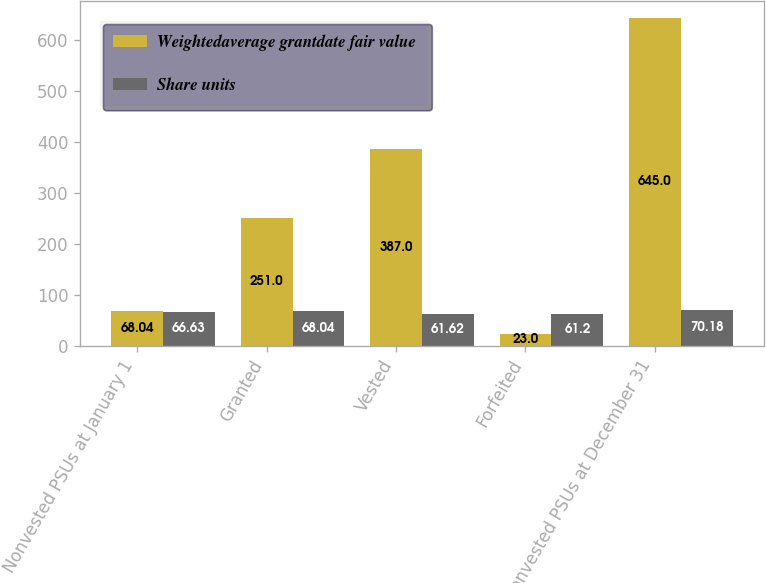Convert chart to OTSL. <chart><loc_0><loc_0><loc_500><loc_500><stacked_bar_chart><ecel><fcel>Nonvested PSUs at January 1<fcel>Granted<fcel>Vested<fcel>Forfeited<fcel>Nonvested PSUs at December 31<nl><fcel>Weightedaverage grantdate fair value<fcel>68.04<fcel>251<fcel>387<fcel>23<fcel>645<nl><fcel>Share units<fcel>66.63<fcel>68.04<fcel>61.62<fcel>61.2<fcel>70.18<nl></chart> 